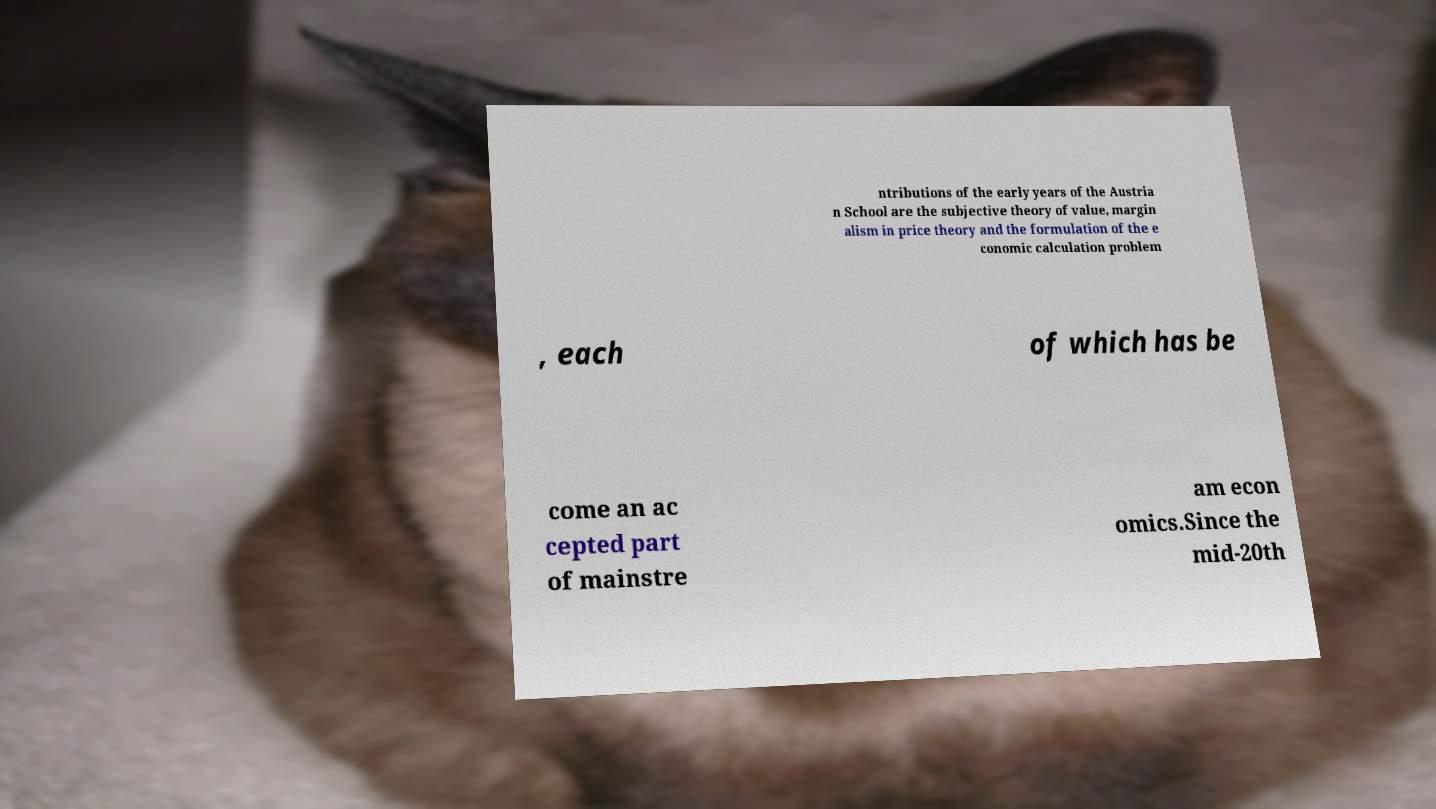For documentation purposes, I need the text within this image transcribed. Could you provide that? ntributions of the early years of the Austria n School are the subjective theory of value, margin alism in price theory and the formulation of the e conomic calculation problem , each of which has be come an ac cepted part of mainstre am econ omics.Since the mid-20th 